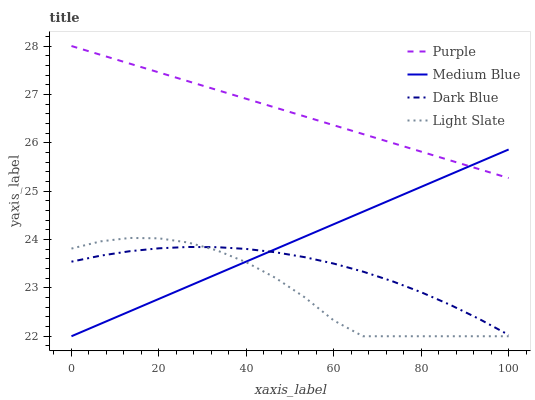Does Light Slate have the minimum area under the curve?
Answer yes or no. Yes. Does Purple have the maximum area under the curve?
Answer yes or no. Yes. Does Dark Blue have the minimum area under the curve?
Answer yes or no. No. Does Dark Blue have the maximum area under the curve?
Answer yes or no. No. Is Purple the smoothest?
Answer yes or no. Yes. Is Light Slate the roughest?
Answer yes or no. Yes. Is Dark Blue the smoothest?
Answer yes or no. No. Is Dark Blue the roughest?
Answer yes or no. No. Does Dark Blue have the lowest value?
Answer yes or no. No. Does Purple have the highest value?
Answer yes or no. Yes. Does Medium Blue have the highest value?
Answer yes or no. No. Is Dark Blue less than Purple?
Answer yes or no. Yes. Is Purple greater than Dark Blue?
Answer yes or no. Yes. Does Medium Blue intersect Purple?
Answer yes or no. Yes. Is Medium Blue less than Purple?
Answer yes or no. No. Is Medium Blue greater than Purple?
Answer yes or no. No. Does Dark Blue intersect Purple?
Answer yes or no. No. 